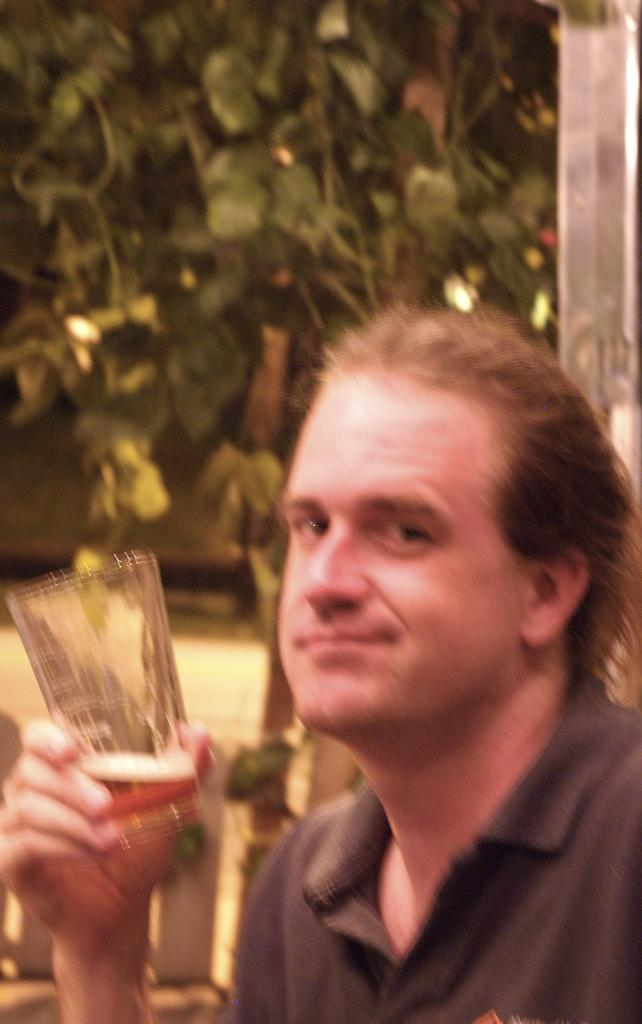Who is present in the image? There is a man in the image. What is the man wearing? The man is wearing a black t-shirt. What is the man holding in his hands? The man is holding a glass in his hands. What can be seen in the background of the image? There is a tree visible behind the man. What games are being played during this week in the image? There is no indication of any games being played or any reference to a specific week in the image. 